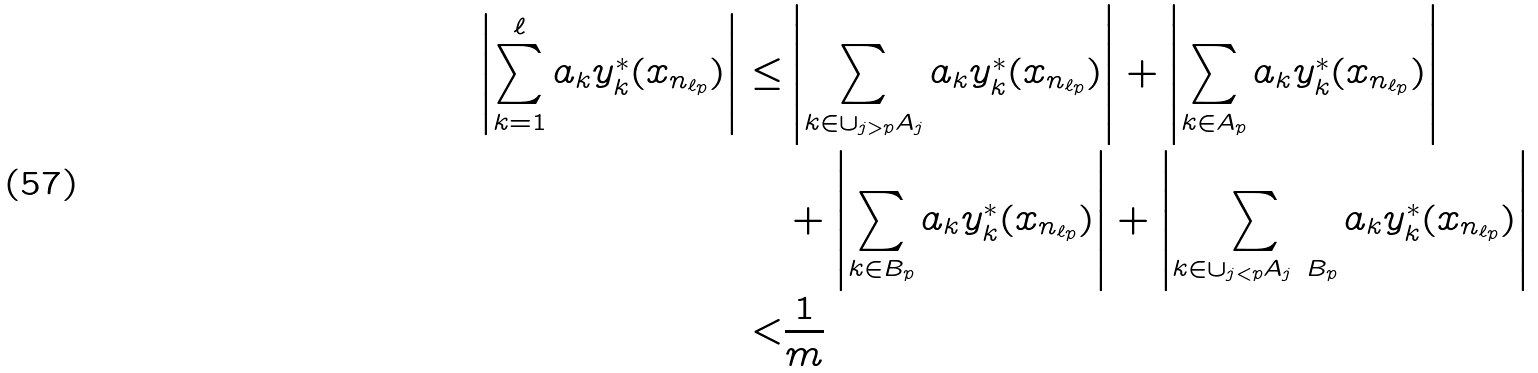<formula> <loc_0><loc_0><loc_500><loc_500>\left | \sum _ { k = 1 } ^ { \ell } a _ { k } y _ { k } ^ { * } ( x _ { n _ { \ell _ { p } } } ) \right | \leq & \left | \sum _ { k \in \cup _ { j > p } A _ { j } } a _ { k } y _ { k } ^ { * } ( x _ { n _ { \ell _ { p } } } ) \right | + \left | \sum _ { k \in A _ { p } } a _ { k } y _ { k } ^ { * } ( x _ { n _ { \ell _ { p } } } ) \right | \\ & + \left | \sum _ { k \in B _ { p } } a _ { k } y _ { k } ^ { * } ( x _ { n _ { \ell _ { p } } } ) \right | + \left | \sum _ { k \in \cup _ { j < p } A _ { j } \ B _ { p } } a _ { k } y _ { k } ^ { * } ( x _ { n _ { \ell _ { p } } } ) \right | \\ < & \frac { 1 } { m }</formula> 